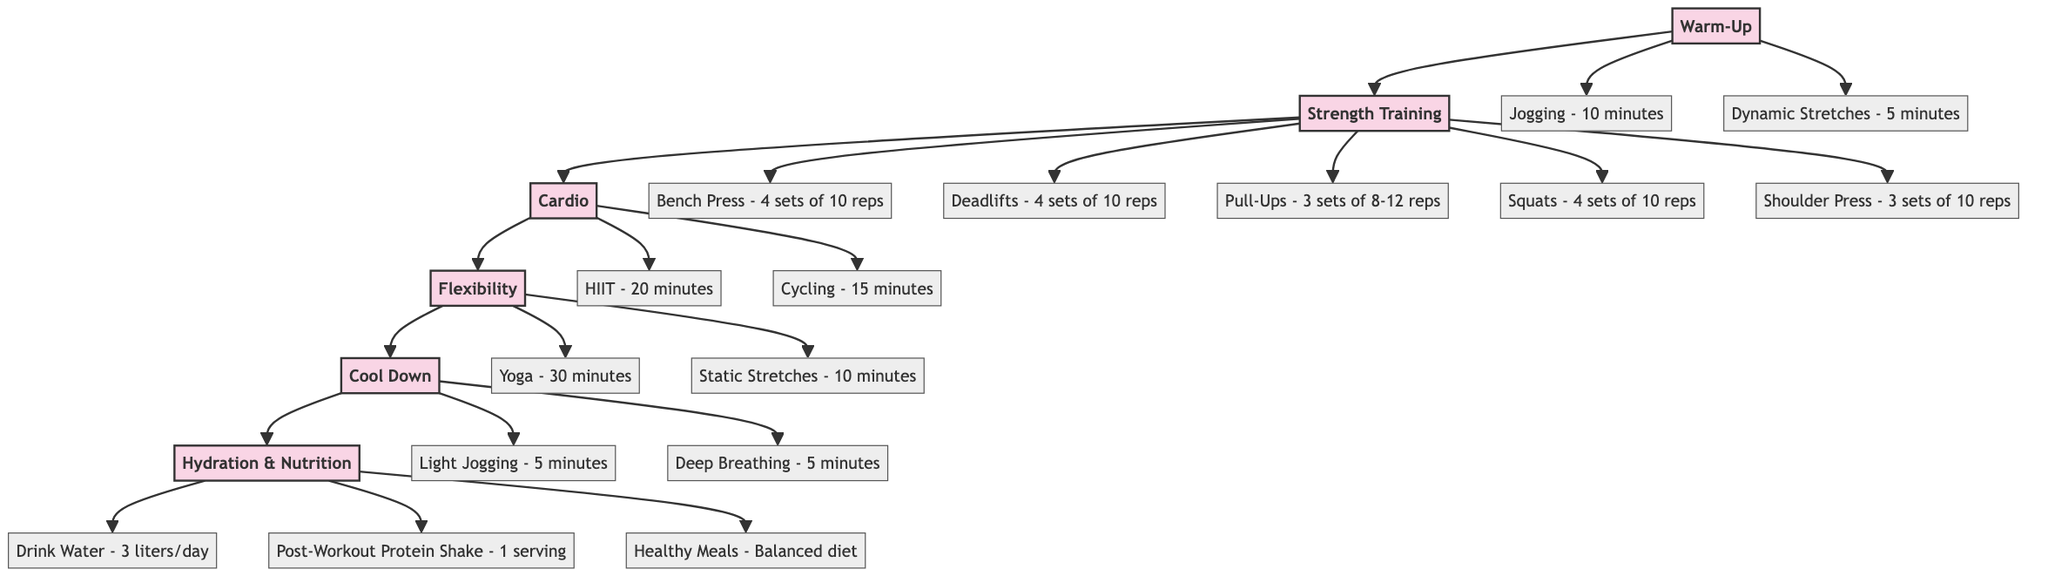What is the first block in the diagram? The first block is labeled as "Warm-Up." In a flowchart, the first block visually represents the starting point of the routine.
Answer: Warm-Up How many exercises are listed under Strength Training? Under the Strength Training block, there are a total of five exercises mentioned: Bench Press, Deadlifts, Pull-Ups, Squats, and Shoulder Press. Counting these gives us five exercises.
Answer: 5 What type of exercises are included in the Flexibility block? The Flexibility block contains Yoga and Static Stretches, which are types of exercises aimed at improving flexibility. Both activities focus on stretching and releasing muscle tension.
Answer: Yoga, Static Stretches What is the total duration of the Cardio exercises? The Cardio section lists HIIT for 20 minutes and Cycling for 15 minutes. Adding these two times together gives a total of 35 minutes for Cardio exercises.
Answer: 35 minutes Which block follows Strength Training in the diagram? After the Strength Training block, the diagram shows an arrow leading to the Cardio block, indicating the flow of the workout routine.
Answer: Cardio How many total sets of exercises are specified in the Strength Training section? The Strength Training section includes exercises with the following sets: 4 sets for Bench Press, Deadlifts, and Squats; 3 sets for Pull-Ups and Shoulder Press. Adding these sets together gives a total of 18 sets (4 + 4 + 3 + 4 + 3).
Answer: 18 sets Which block contains hydration and nutrition information? The Hydration & Nutrition block is designated for all elements related to hydration and nutritional needs, clearly labeled at the end of the flow of exercises.
Answer: Hydration & Nutrition What is the duration of the Warm-Up phase? The Warm-Up consists of 10 minutes of Jogging and 5 minutes of Dynamic Stretches, making the total duration of the Warm-Up phase 15 minutes.
Answer: 15 minutes 